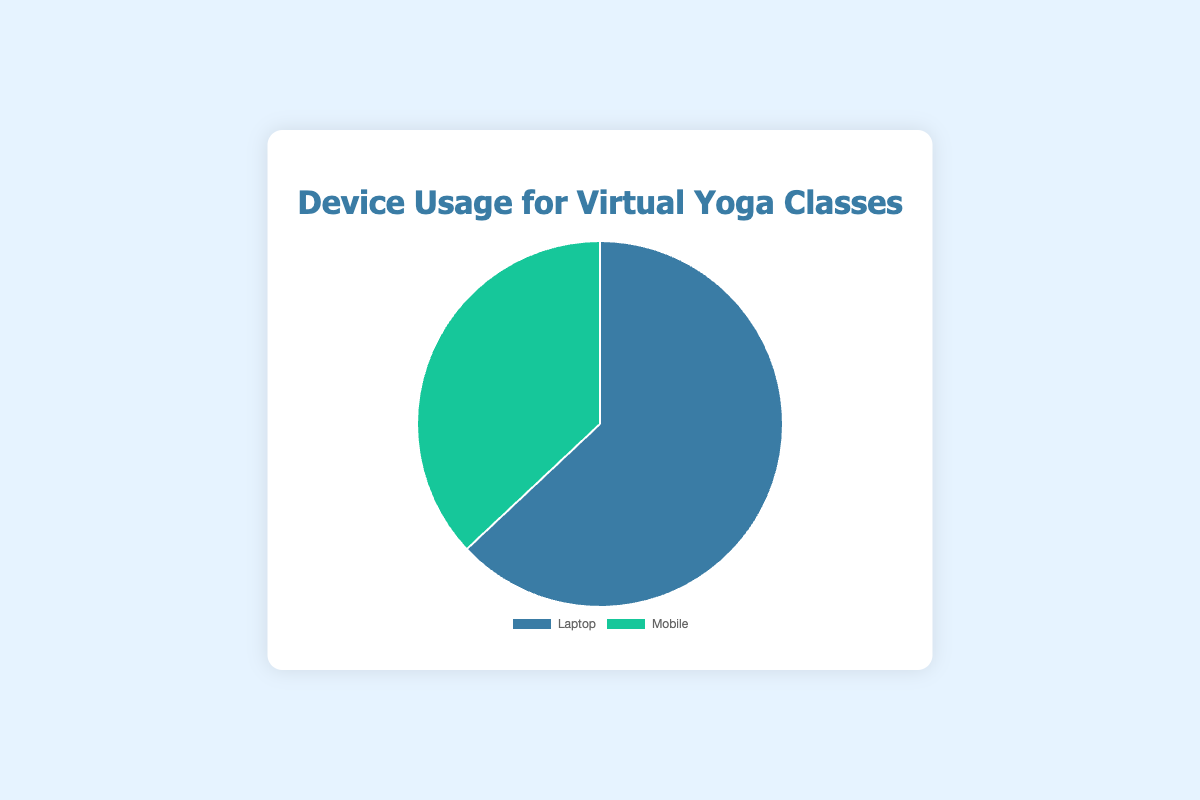What percentage of users access the virtual yoga classes using laptops? According to the chart, the portion of the pie representing laptop usage is labeled as 63%.
Answer: 63% What percentage of users access the virtual yoga classes using mobile devices? The chart indicates that the portion representing mobile usage is labeled as 37%.
Answer: 37% Which device is more commonly used for virtual yoga classes? By comparing the sections of the pie chart, it's clear that the laptop section is larger than the mobile section, indicating that laptops are more commonly used.
Answer: Laptop How much higher is the laptop usage compared to mobile usage? To find how much higher the laptop usage is, subtract the mobile percentage from the laptop percentage: 63% - 37% = 26%.
Answer: 26% What fraction of users use laptops for virtual yoga classes? The laptop usage is 63%. To convert this percentage to a fraction: 63/100 = 63%.
Answer: 63/100 Are the proportions of device usage the same or different? The pie chart shows different sizes for each section, with the laptop at 63% and the mobile at 37%, indicating that the proportions are different.
Answer: Different What is the ratio of laptop usage to mobile usage? To find the ratio, divide the laptop usage by the mobile usage: 63% / 37%. Simplifying this ratio gives approximately 1.7:1.
Answer: 1.7:1 What is the combined percentage of all device usage for virtual yoga classes? Adding the two percentages together, laptop (63%) and mobile (37%), gives a total of 63% + 37% = 100%.
Answer: 100% What color represents mobile usage in the chart? The pie chart visually shows the section labeled "Mobile" in green color.
Answer: Green If you were to split the devices into two equal usage categories, which device usage would be above the halfway mark? The halfway mark in percentage terms is 50%. Comparing this with the chart, only the laptop usage at 63% is above this halfway mark.
Answer: Laptop 